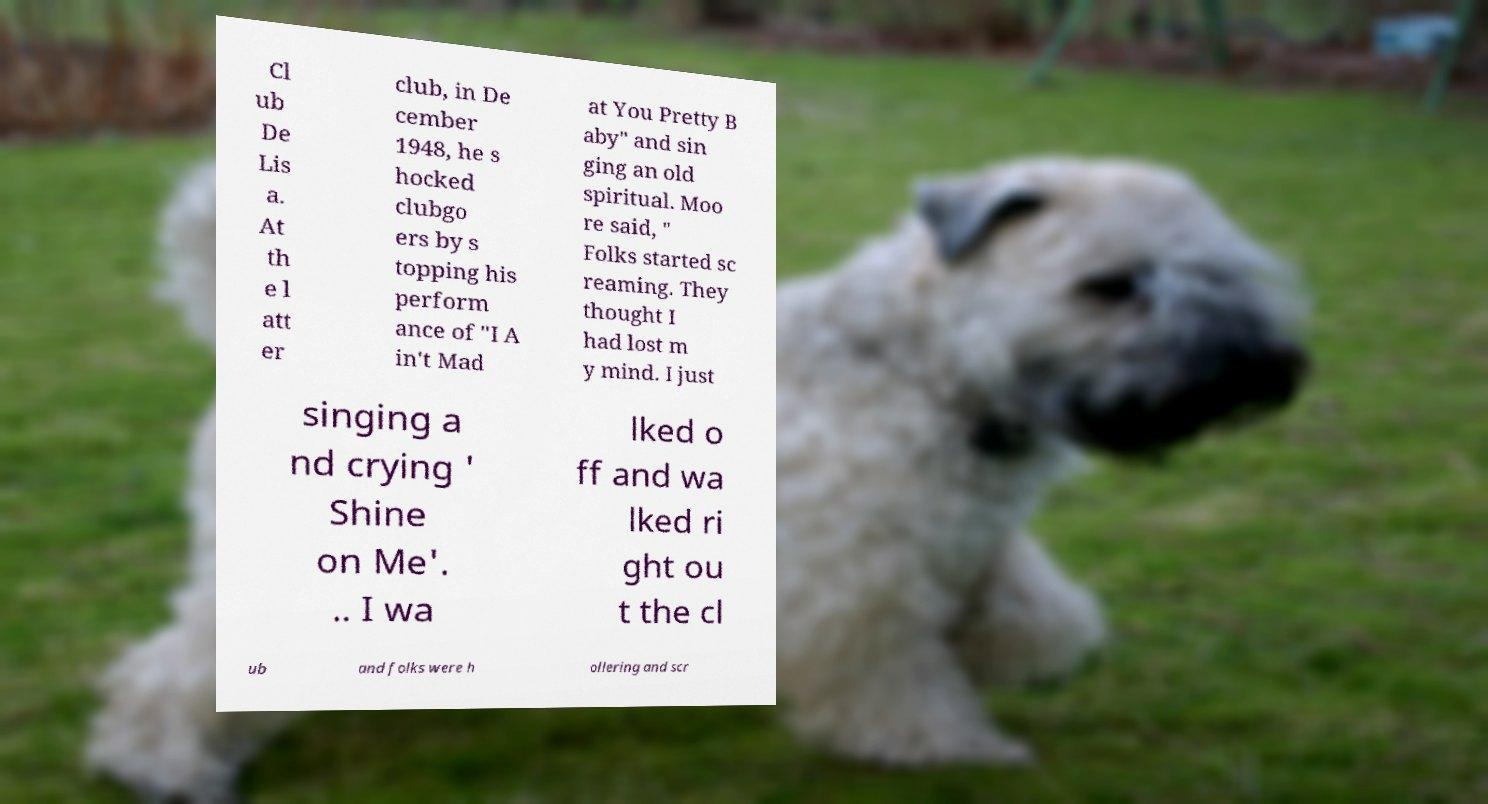I need the written content from this picture converted into text. Can you do that? Cl ub De Lis a. At th e l att er club, in De cember 1948, he s hocked clubgo ers by s topping his perform ance of "I A in't Mad at You Pretty B aby" and sin ging an old spiritual. Moo re said, " Folks started sc reaming. They thought I had lost m y mind. I just singing a nd crying ' Shine on Me'. .. I wa lked o ff and wa lked ri ght ou t the cl ub and folks were h ollering and scr 